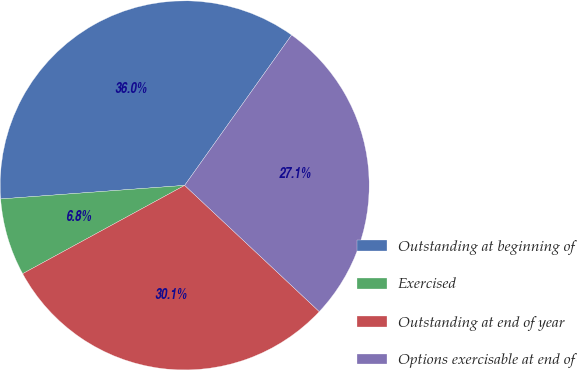Convert chart. <chart><loc_0><loc_0><loc_500><loc_500><pie_chart><fcel>Outstanding at beginning of<fcel>Exercised<fcel>Outstanding at end of year<fcel>Options exercisable at end of<nl><fcel>36.01%<fcel>6.77%<fcel>30.07%<fcel>27.15%<nl></chart> 